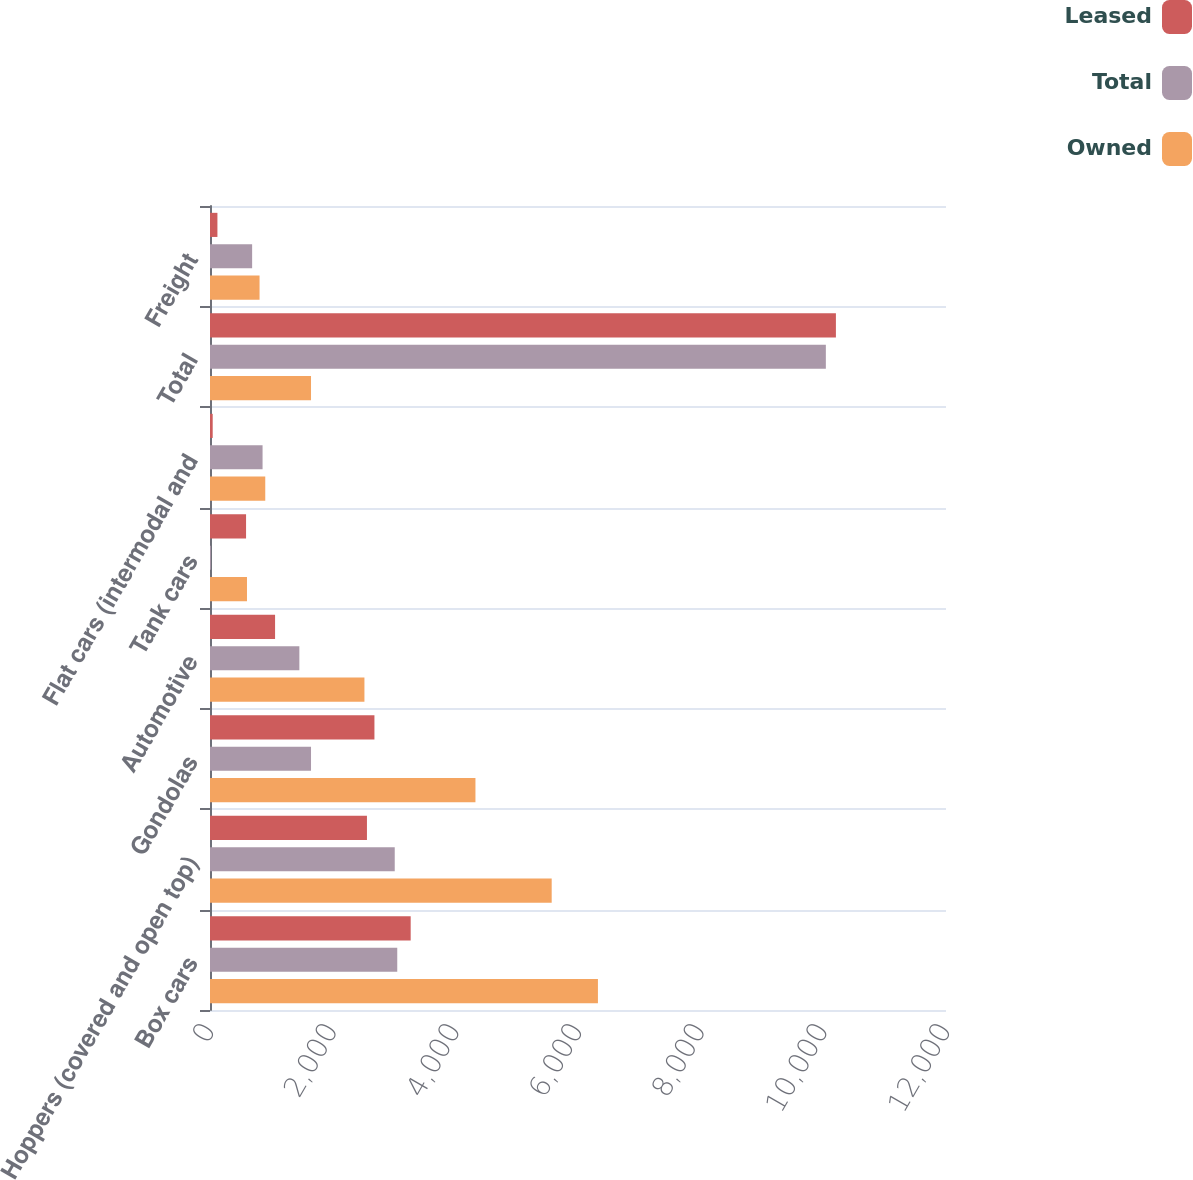Convert chart. <chart><loc_0><loc_0><loc_500><loc_500><stacked_bar_chart><ecel><fcel>Box cars<fcel>Hoppers (covered and open top)<fcel>Gondolas<fcel>Automotive<fcel>Tank cars<fcel>Flat cars (intermodal and<fcel>Total<fcel>Freight<nl><fcel>Leased<fcel>3272<fcel>2559<fcel>2681<fcel>1061<fcel>588<fcel>44<fcel>10205<fcel>121<nl><fcel>Total<fcel>3053<fcel>3012<fcel>1647<fcel>1457<fcel>15<fcel>857<fcel>10041<fcel>687<nl><fcel>Owned<fcel>6325<fcel>5571<fcel>4328<fcel>2518<fcel>603<fcel>901<fcel>1647<fcel>808<nl></chart> 